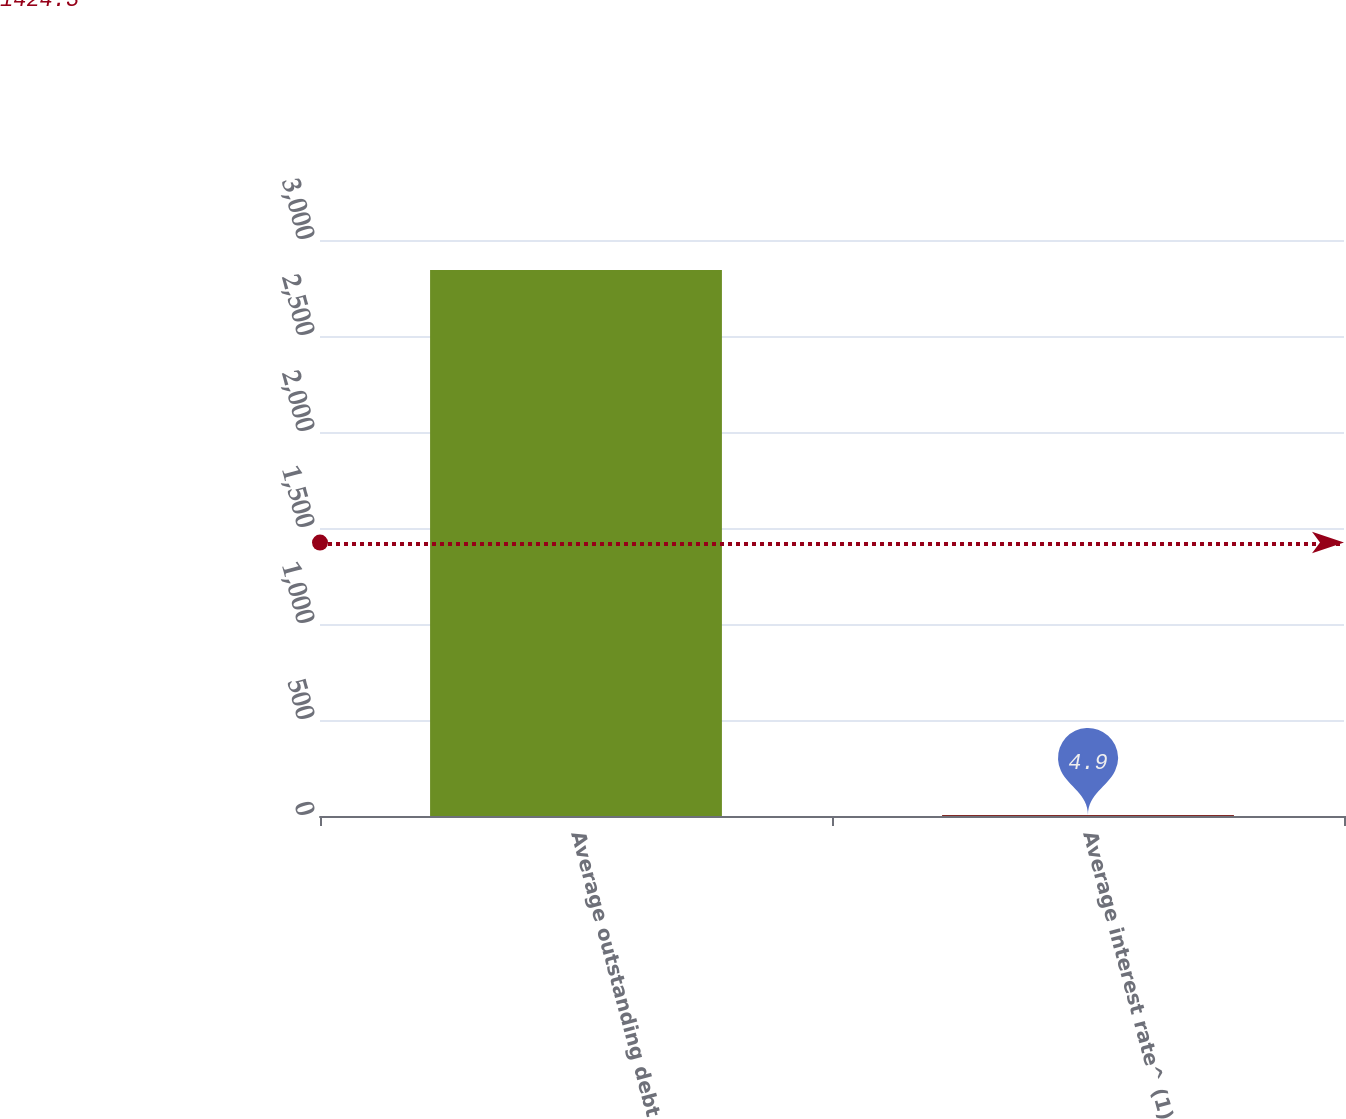<chart> <loc_0><loc_0><loc_500><loc_500><bar_chart><fcel>Average outstanding debt<fcel>Average interest rate^ (1)<nl><fcel>2843.7<fcel>4.9<nl></chart> 